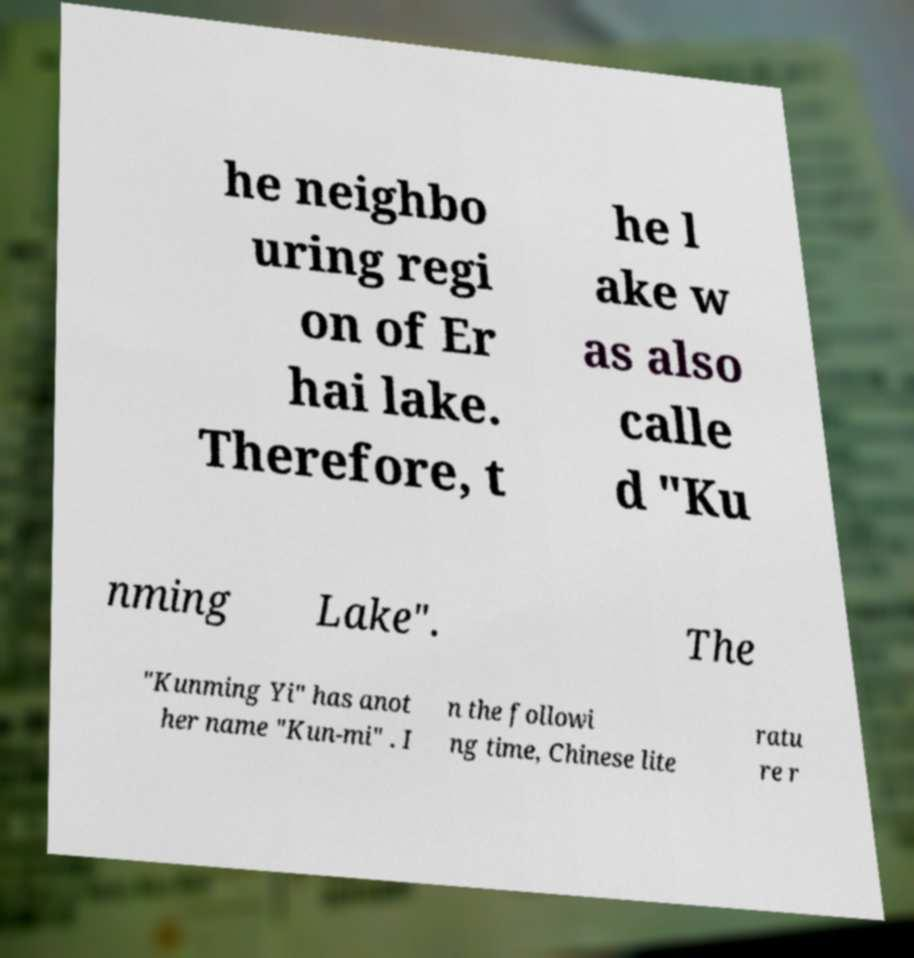Please read and relay the text visible in this image. What does it say? he neighbo uring regi on of Er hai lake. Therefore, t he l ake w as also calle d "Ku nming Lake". The "Kunming Yi" has anot her name "Kun-mi" . I n the followi ng time, Chinese lite ratu re r 